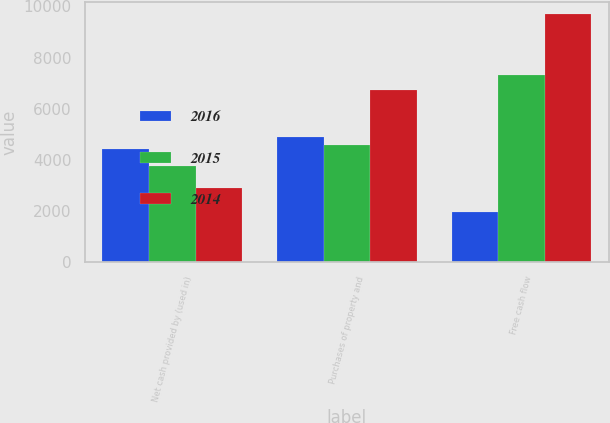Convert chart. <chart><loc_0><loc_0><loc_500><loc_500><stacked_bar_chart><ecel><fcel>Net cash provided by (used in)<fcel>Purchases of property and<fcel>Free cash flow<nl><fcel>2016<fcel>4432<fcel>4893<fcel>1949<nl><fcel>2015<fcel>3763<fcel>4589<fcel>7331<nl><fcel>2014<fcel>2911<fcel>6737<fcel>9706<nl></chart> 